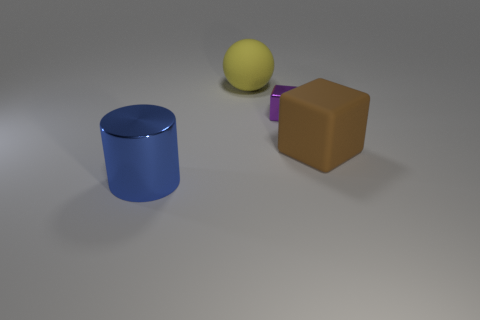Is the number of large blue shiny objects that are behind the large matte sphere greater than the number of purple things that are in front of the brown rubber thing?
Keep it short and to the point. No. There is a large brown object; does it have the same shape as the matte object on the left side of the rubber block?
Your answer should be very brief. No. Is the size of the metallic thing right of the cylinder the same as the rubber thing that is right of the big yellow object?
Make the answer very short. No. There is a large rubber thing on the right side of the metal object behind the brown rubber block; are there any blocks that are right of it?
Ensure brevity in your answer.  No. Are there fewer purple metal objects in front of the metal block than large blue objects right of the brown matte block?
Your response must be concise. No. What is the shape of the thing that is made of the same material as the tiny purple cube?
Your response must be concise. Cylinder. How big is the matte thing that is in front of the rubber thing behind the metallic thing that is behind the blue object?
Ensure brevity in your answer.  Large. Is the number of large yellow rubber objects greater than the number of matte things?
Offer a very short reply. No. Do the thing that is on the left side of the yellow sphere and the big matte thing in front of the sphere have the same color?
Offer a terse response. No. Is the material of the large thing right of the tiny purple metallic cube the same as the object that is behind the purple block?
Provide a succinct answer. Yes. 